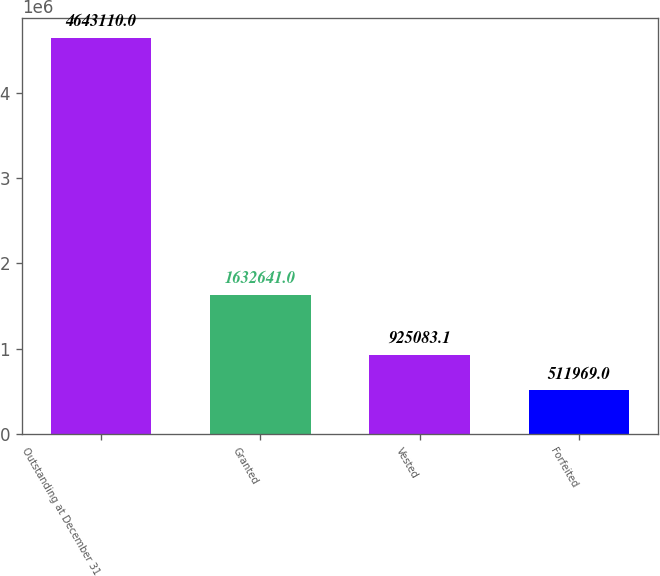Convert chart. <chart><loc_0><loc_0><loc_500><loc_500><bar_chart><fcel>Outstanding at December 31<fcel>Granted<fcel>Vested<fcel>Forfeited<nl><fcel>4.64311e+06<fcel>1.63264e+06<fcel>925083<fcel>511969<nl></chart> 